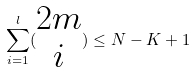Convert formula to latex. <formula><loc_0><loc_0><loc_500><loc_500>\sum _ { i = 1 } ^ { l } ( \begin{matrix} 2 m \\ i \end{matrix} ) \leq N - K + 1</formula> 